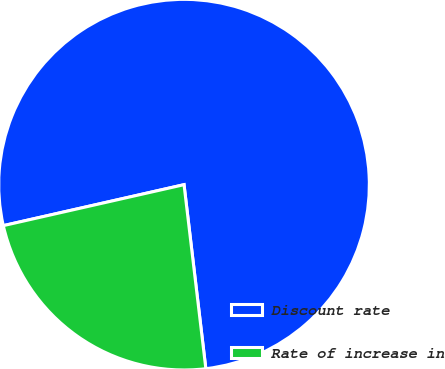Convert chart. <chart><loc_0><loc_0><loc_500><loc_500><pie_chart><fcel>Discount rate<fcel>Rate of increase in<nl><fcel>76.67%<fcel>23.33%<nl></chart> 